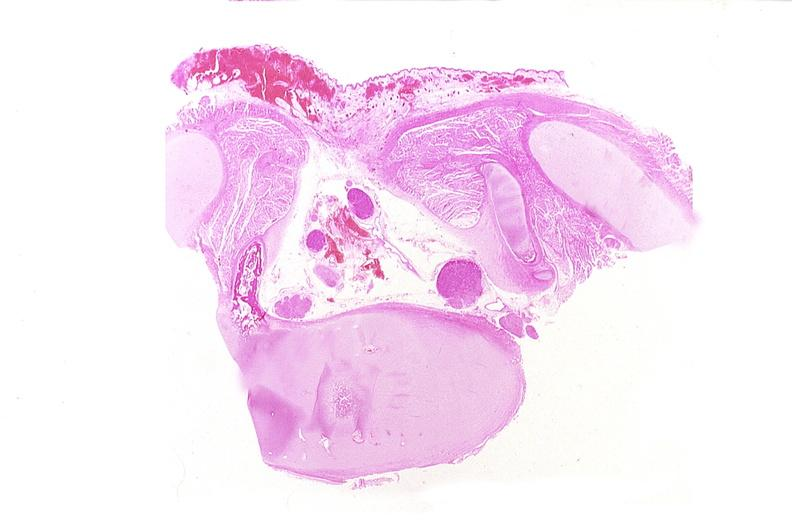what is present?
Answer the question using a single word or phrase. Nervous 